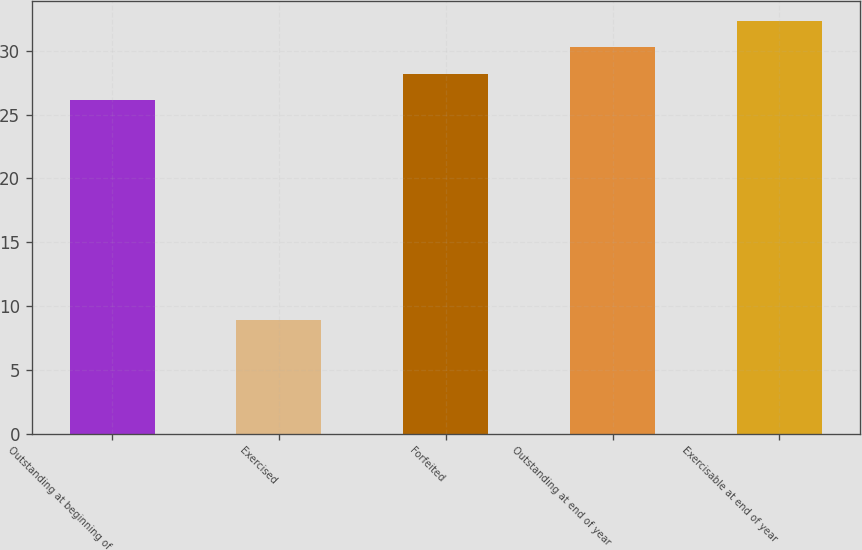<chart> <loc_0><loc_0><loc_500><loc_500><bar_chart><fcel>Outstanding at beginning of<fcel>Exercised<fcel>Forfeited<fcel>Outstanding at end of year<fcel>Exercisable at end of year<nl><fcel>26.14<fcel>8.92<fcel>28.2<fcel>30.26<fcel>32.32<nl></chart> 